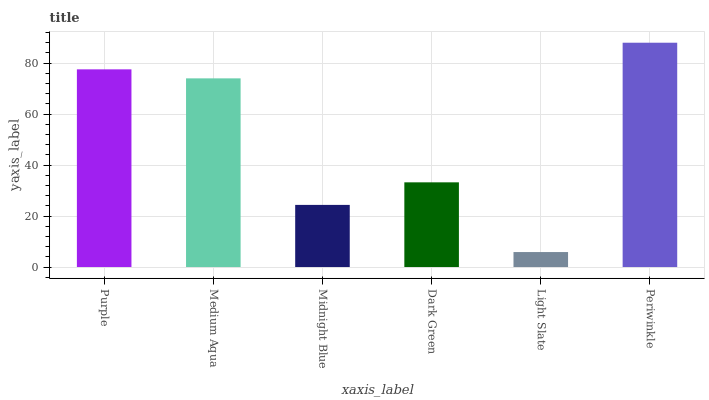Is Light Slate the minimum?
Answer yes or no. Yes. Is Periwinkle the maximum?
Answer yes or no. Yes. Is Medium Aqua the minimum?
Answer yes or no. No. Is Medium Aqua the maximum?
Answer yes or no. No. Is Purple greater than Medium Aqua?
Answer yes or no. Yes. Is Medium Aqua less than Purple?
Answer yes or no. Yes. Is Medium Aqua greater than Purple?
Answer yes or no. No. Is Purple less than Medium Aqua?
Answer yes or no. No. Is Medium Aqua the high median?
Answer yes or no. Yes. Is Dark Green the low median?
Answer yes or no. Yes. Is Light Slate the high median?
Answer yes or no. No. Is Periwinkle the low median?
Answer yes or no. No. 